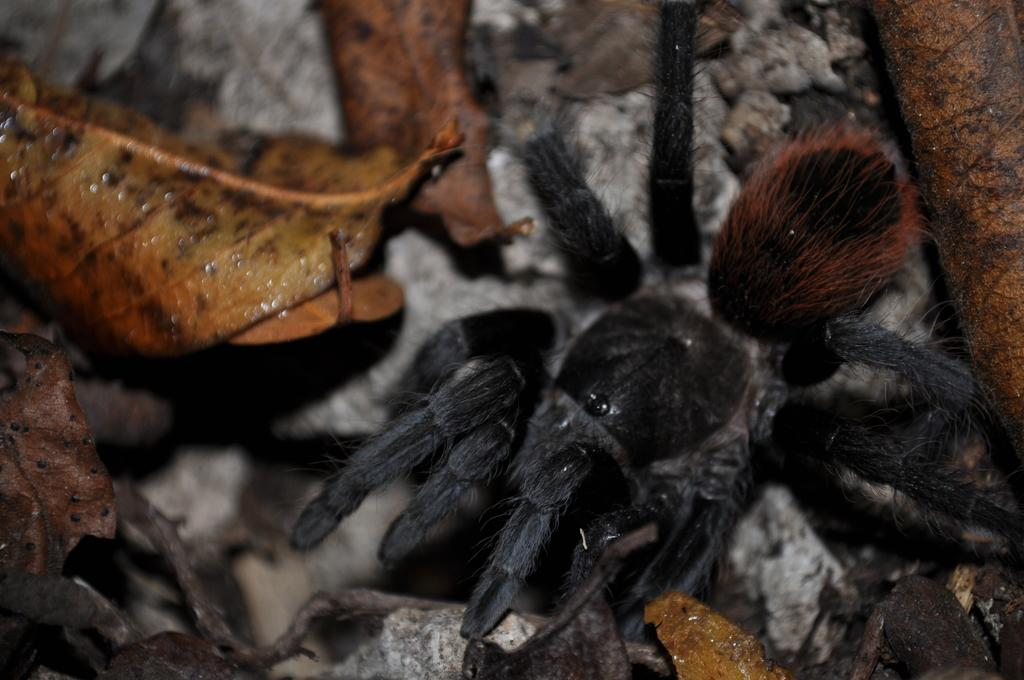What type of animal can be seen in the image? There is a black spider in the image. Where is the spider located? The spider is on the ground. What type of vegetation or plant material is visible in the image? Dry leaves are visible in the image. What type of inorganic material is present in the image? Stones are present in the image. What color is the toy scarf that the spider is trying to start in the image? There is no toy or scarf present in the image, and the spider is not attempting to start anything. 